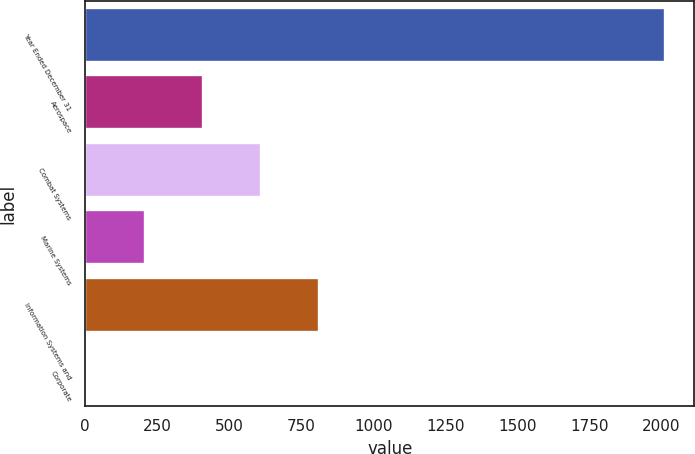Convert chart. <chart><loc_0><loc_0><loc_500><loc_500><bar_chart><fcel>Year Ended December 31<fcel>Aerospace<fcel>Combat Systems<fcel>Marine Systems<fcel>Information Systems and<fcel>Corporate<nl><fcel>2013<fcel>409<fcel>609.5<fcel>208.5<fcel>810<fcel>8<nl></chart> 